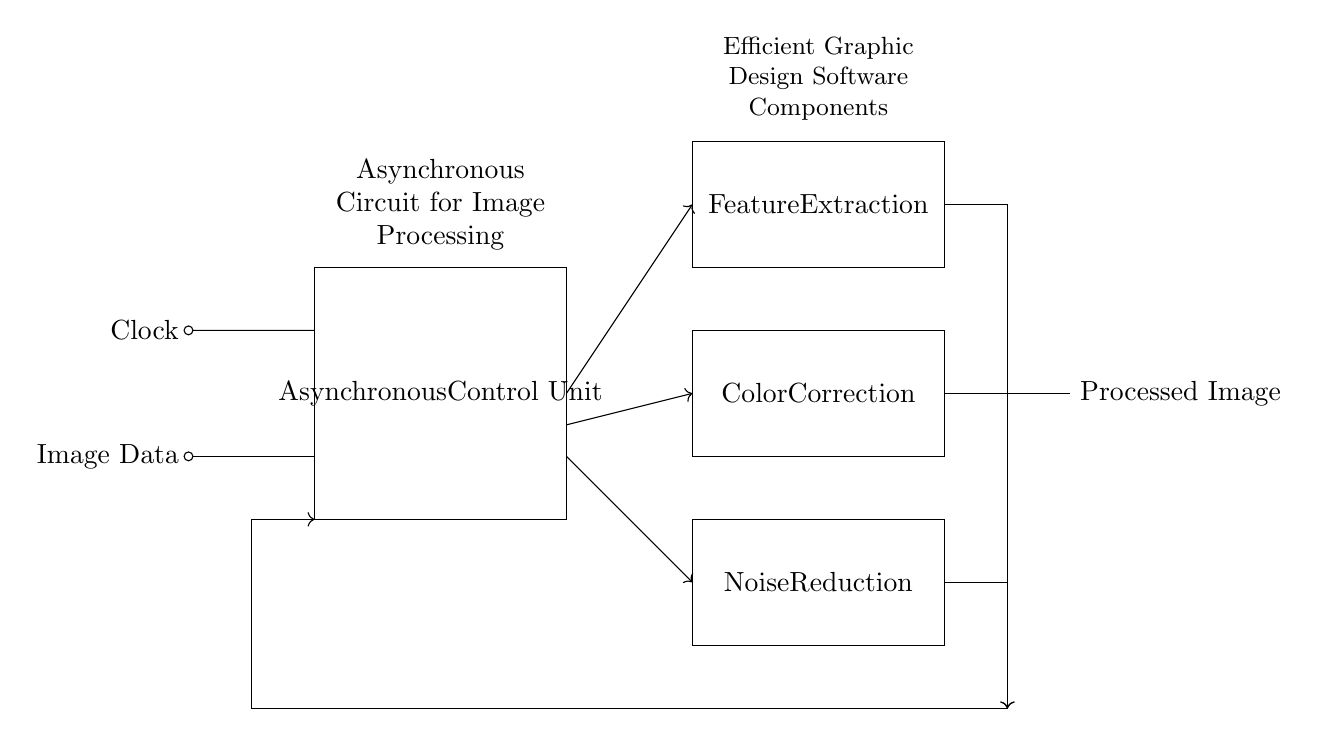What is the main functional unit of the circuit? The main functional unit is labeled as the "Asynchronous Control Unit," which indicates its significance in managing the operations of the circuit.
Answer: Asynchronous Control Unit How many image processing units are present in the circuit? There are three image processing units represented in the diagram: Feature Extraction, Color Correction, and Noise Reduction, making a total of three units.
Answer: Three What is the output of the circuit? The output of the circuit is labeled as "Processed Image," indicating the final result after the image processing units have performed their functions.
Answer: Processed Image What type of processing does the "Color Correction" unit perform? The "Color Correction" unit is explicitly labeled and suggests it processes the image to correct color imbalances, hence it is related to color adjustments.
Answer: Color Adjustment Which component receives image data? The input signal labeled "Image Data" is the first element in the circuit, indicating that it receives the initial data for processing.
Answer: Image Data What do the arrows in the diagram indicate? The arrows represent the flow of data, showing the direction in which the signals move from one component to another, indicating a sequential process in image processing.
Answer: Flow of Data 